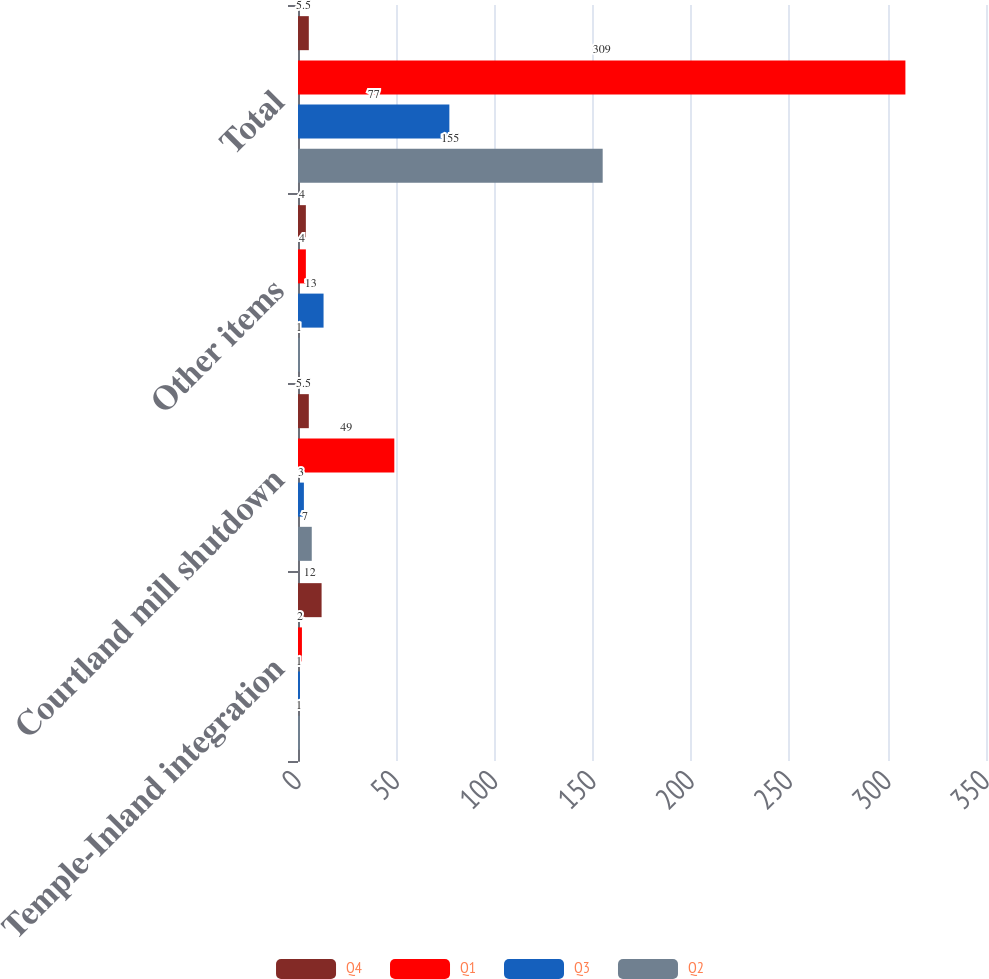Convert chart to OTSL. <chart><loc_0><loc_0><loc_500><loc_500><stacked_bar_chart><ecel><fcel>Temple-Inland integration<fcel>Courtland mill shutdown<fcel>Other items<fcel>Total<nl><fcel>Q4<fcel>12<fcel>5.5<fcel>4<fcel>5.5<nl><fcel>Q1<fcel>2<fcel>49<fcel>4<fcel>309<nl><fcel>Q3<fcel>1<fcel>3<fcel>13<fcel>77<nl><fcel>Q2<fcel>1<fcel>7<fcel>1<fcel>155<nl></chart> 